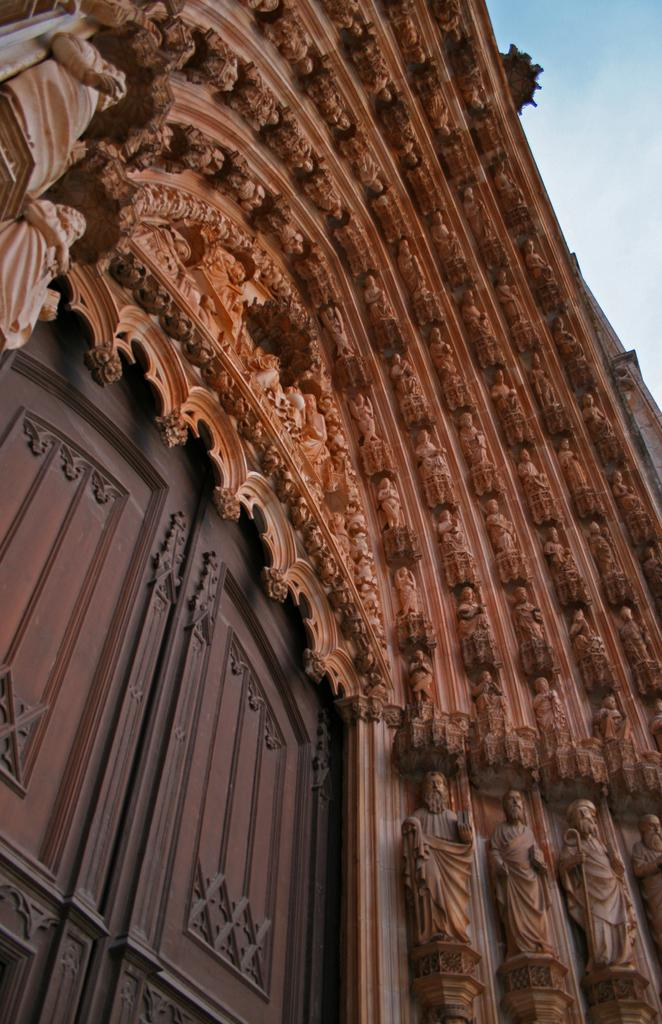What is one of the main features of the image? There is a door in the image. What other objects can be seen in the image? There are statues in the image. What can be seen in the distance in the image? The sky is visible in the background of the image. How many eyes can be seen on the statues in the image? There is no mention of eyes or any specific details about the statues in the image. 